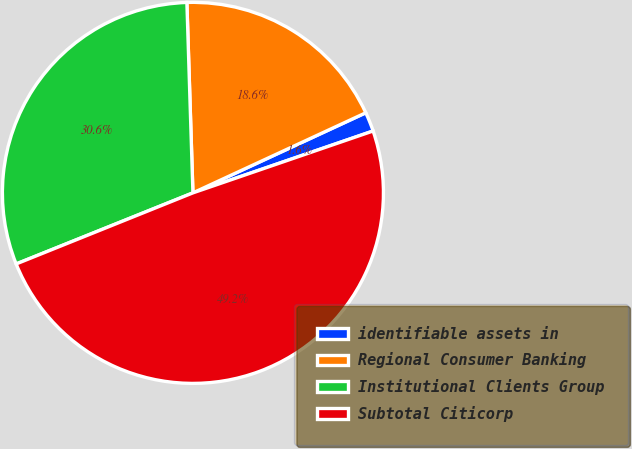<chart> <loc_0><loc_0><loc_500><loc_500><pie_chart><fcel>identifiable assets in<fcel>Regional Consumer Banking<fcel>Institutional Clients Group<fcel>Subtotal Citicorp<nl><fcel>1.64%<fcel>18.6%<fcel>30.58%<fcel>49.18%<nl></chart> 